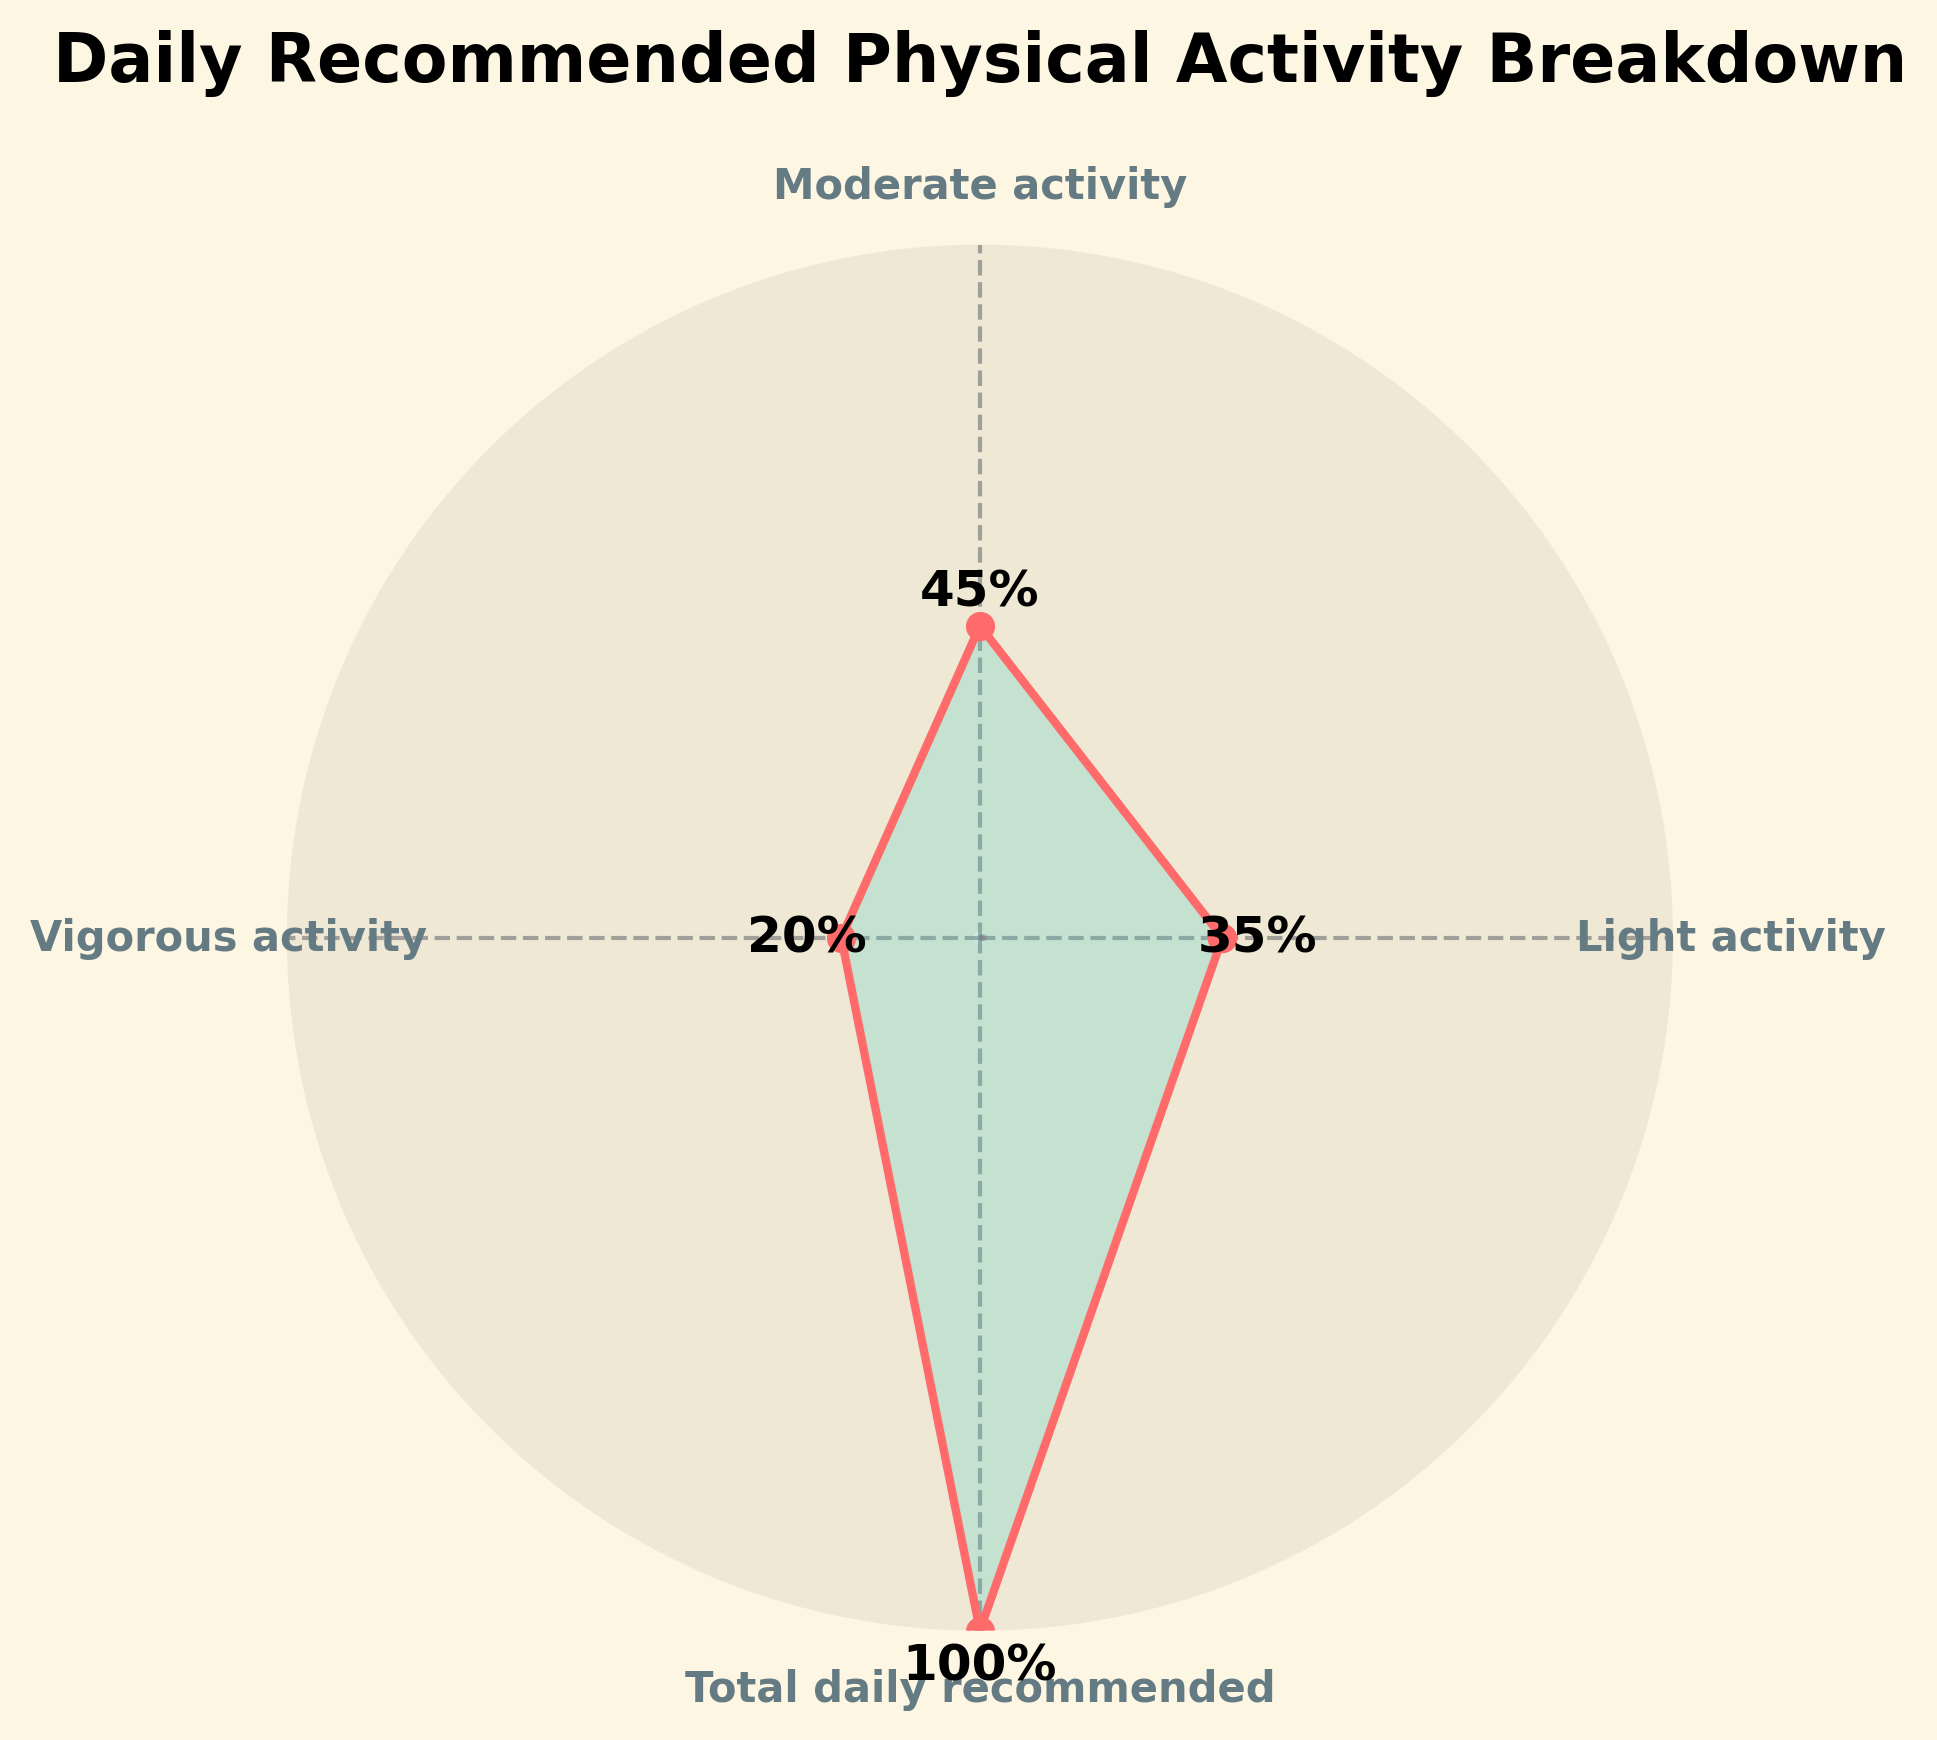What is the title of the chart? The title of the chart is indicated at the top and usually provides a brief summary of what the chart is about.
Answer: Daily Recommended Physical Activity Breakdown What are the three different intensity levels represented in the chart? The different intensity levels can be identified from the labels around the circular axis of the gauge chart. They are "Light activity," "Moderate activity," and "Vigorous activity."
Answer: Light activity, Moderate activity, Vigorous activity How much percentage of the daily recommended activity is achieved through moderate activity? The percentage of each activity level is labeled near the corresponding segment in the gauge chart. For moderate activity, it is labeled as 45%.
Answer: 45% What is the total percentage achieved by light and vigorous activities combined? Identify the percentage given for light activity (35%) and vigorous activity (20%), then add them together: 35% + 20% = 55%.
Answer: 55% Which activity intensity level achieves the highest percentage of the daily recommended activity? Compare the percentages labeled for each activity intensity level. Moderate activity has the highest percentage at 45%.
Answer: Moderate activity What is the difference in percentage between light activity and vigorous activity? Subtract the smaller percentage of vigorous activity (20%) from the larger percentage of light activity (35%): 35% - 20% = 15%.
Answer: 15% Is the total percentage of all activities combined equal to the daily recommended activity? Sum up the percentages of light activity (35%), moderate activity (45%), and vigorous activity (20%) to see if they equal 100%: 35% + 45% + 20% = 100%.
Answer: Yes By how much does the percentage for moderate activity exceed that for vigorous activity? The percentage for moderate activity is 45%, and for vigorous activity, it is 20%. The difference is calculated as: 45% - 20% = 25%.
Answer: 25% What percentage should be increased in light activity to achieve exactly half of the daily recommended activity? The current percentage for light activity is 35%. To achieve half of the daily recommended activity (50%), increase it by: 50% - 35% = 15%.
Answer: 15% Which activity intensity level is closest to achieving one-third of the daily recommended activity? One-third of the daily recommended activity is approximately 33.33%. Comparing the percentages: light activity (35%), moderate activity (45%), and vigorous activity (20%), light activity at 35% is closest to one-third.
Answer: Light activity 